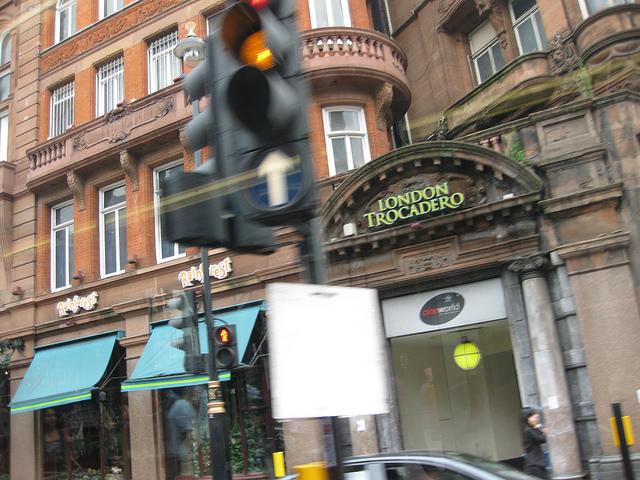Are there any people on the sidewalk?
Give a very brief answer. Yes. What color is the light?
Concise answer only. Yellow. What does the sign over the door say?
Write a very short answer. London trocadero. 